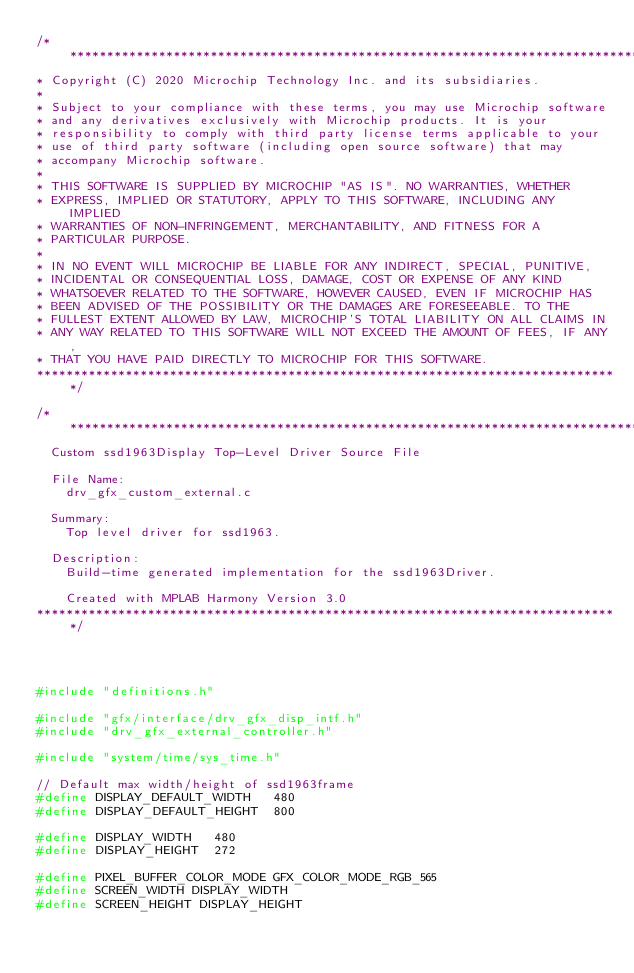<code> <loc_0><loc_0><loc_500><loc_500><_C_>/*******************************************************************************
* Copyright (C) 2020 Microchip Technology Inc. and its subsidiaries.
*
* Subject to your compliance with these terms, you may use Microchip software
* and any derivatives exclusively with Microchip products. It is your
* responsibility to comply with third party license terms applicable to your
* use of third party software (including open source software) that may
* accompany Microchip software.
*
* THIS SOFTWARE IS SUPPLIED BY MICROCHIP "AS IS". NO WARRANTIES, WHETHER
* EXPRESS, IMPLIED OR STATUTORY, APPLY TO THIS SOFTWARE, INCLUDING ANY IMPLIED
* WARRANTIES OF NON-INFRINGEMENT, MERCHANTABILITY, AND FITNESS FOR A
* PARTICULAR PURPOSE.
*
* IN NO EVENT WILL MICROCHIP BE LIABLE FOR ANY INDIRECT, SPECIAL, PUNITIVE,
* INCIDENTAL OR CONSEQUENTIAL LOSS, DAMAGE, COST OR EXPENSE OF ANY KIND
* WHATSOEVER RELATED TO THE SOFTWARE, HOWEVER CAUSED, EVEN IF MICROCHIP HAS
* BEEN ADVISED OF THE POSSIBILITY OR THE DAMAGES ARE FORESEEABLE. TO THE
* FULLEST EXTENT ALLOWED BY LAW, MICROCHIP'S TOTAL LIABILITY ON ALL CLAIMS IN
* ANY WAY RELATED TO THIS SOFTWARE WILL NOT EXCEED THE AMOUNT OF FEES, IF ANY,
* THAT YOU HAVE PAID DIRECTLY TO MICROCHIP FOR THIS SOFTWARE.
*******************************************************************************/

/*******************************************************************************
  Custom ssd1963Display Top-Level Driver Source File

  File Name:
    drv_gfx_custom_external.c

  Summary:
    Top level driver for ssd1963.

  Description:
    Build-time generated implementation for the ssd1963Driver.

    Created with MPLAB Harmony Version 3.0
*******************************************************************************/




#include "definitions.h"

#include "gfx/interface/drv_gfx_disp_intf.h"
#include "drv_gfx_external_controller.h"

#include "system/time/sys_time.h"

// Default max width/height of ssd1963frame
#define DISPLAY_DEFAULT_WIDTH   480
#define DISPLAY_DEFAULT_HEIGHT  800

#define DISPLAY_WIDTH   480
#define DISPLAY_HEIGHT  272

#define PIXEL_BUFFER_COLOR_MODE GFX_COLOR_MODE_RGB_565
#define SCREEN_WIDTH DISPLAY_WIDTH
#define SCREEN_HEIGHT DISPLAY_HEIGHT
</code> 